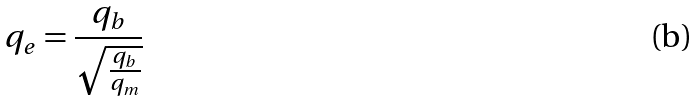Convert formula to latex. <formula><loc_0><loc_0><loc_500><loc_500>q _ { e } = \frac { q _ { b } } { \sqrt { \frac { q _ { b } } { q _ { m } } } }</formula> 